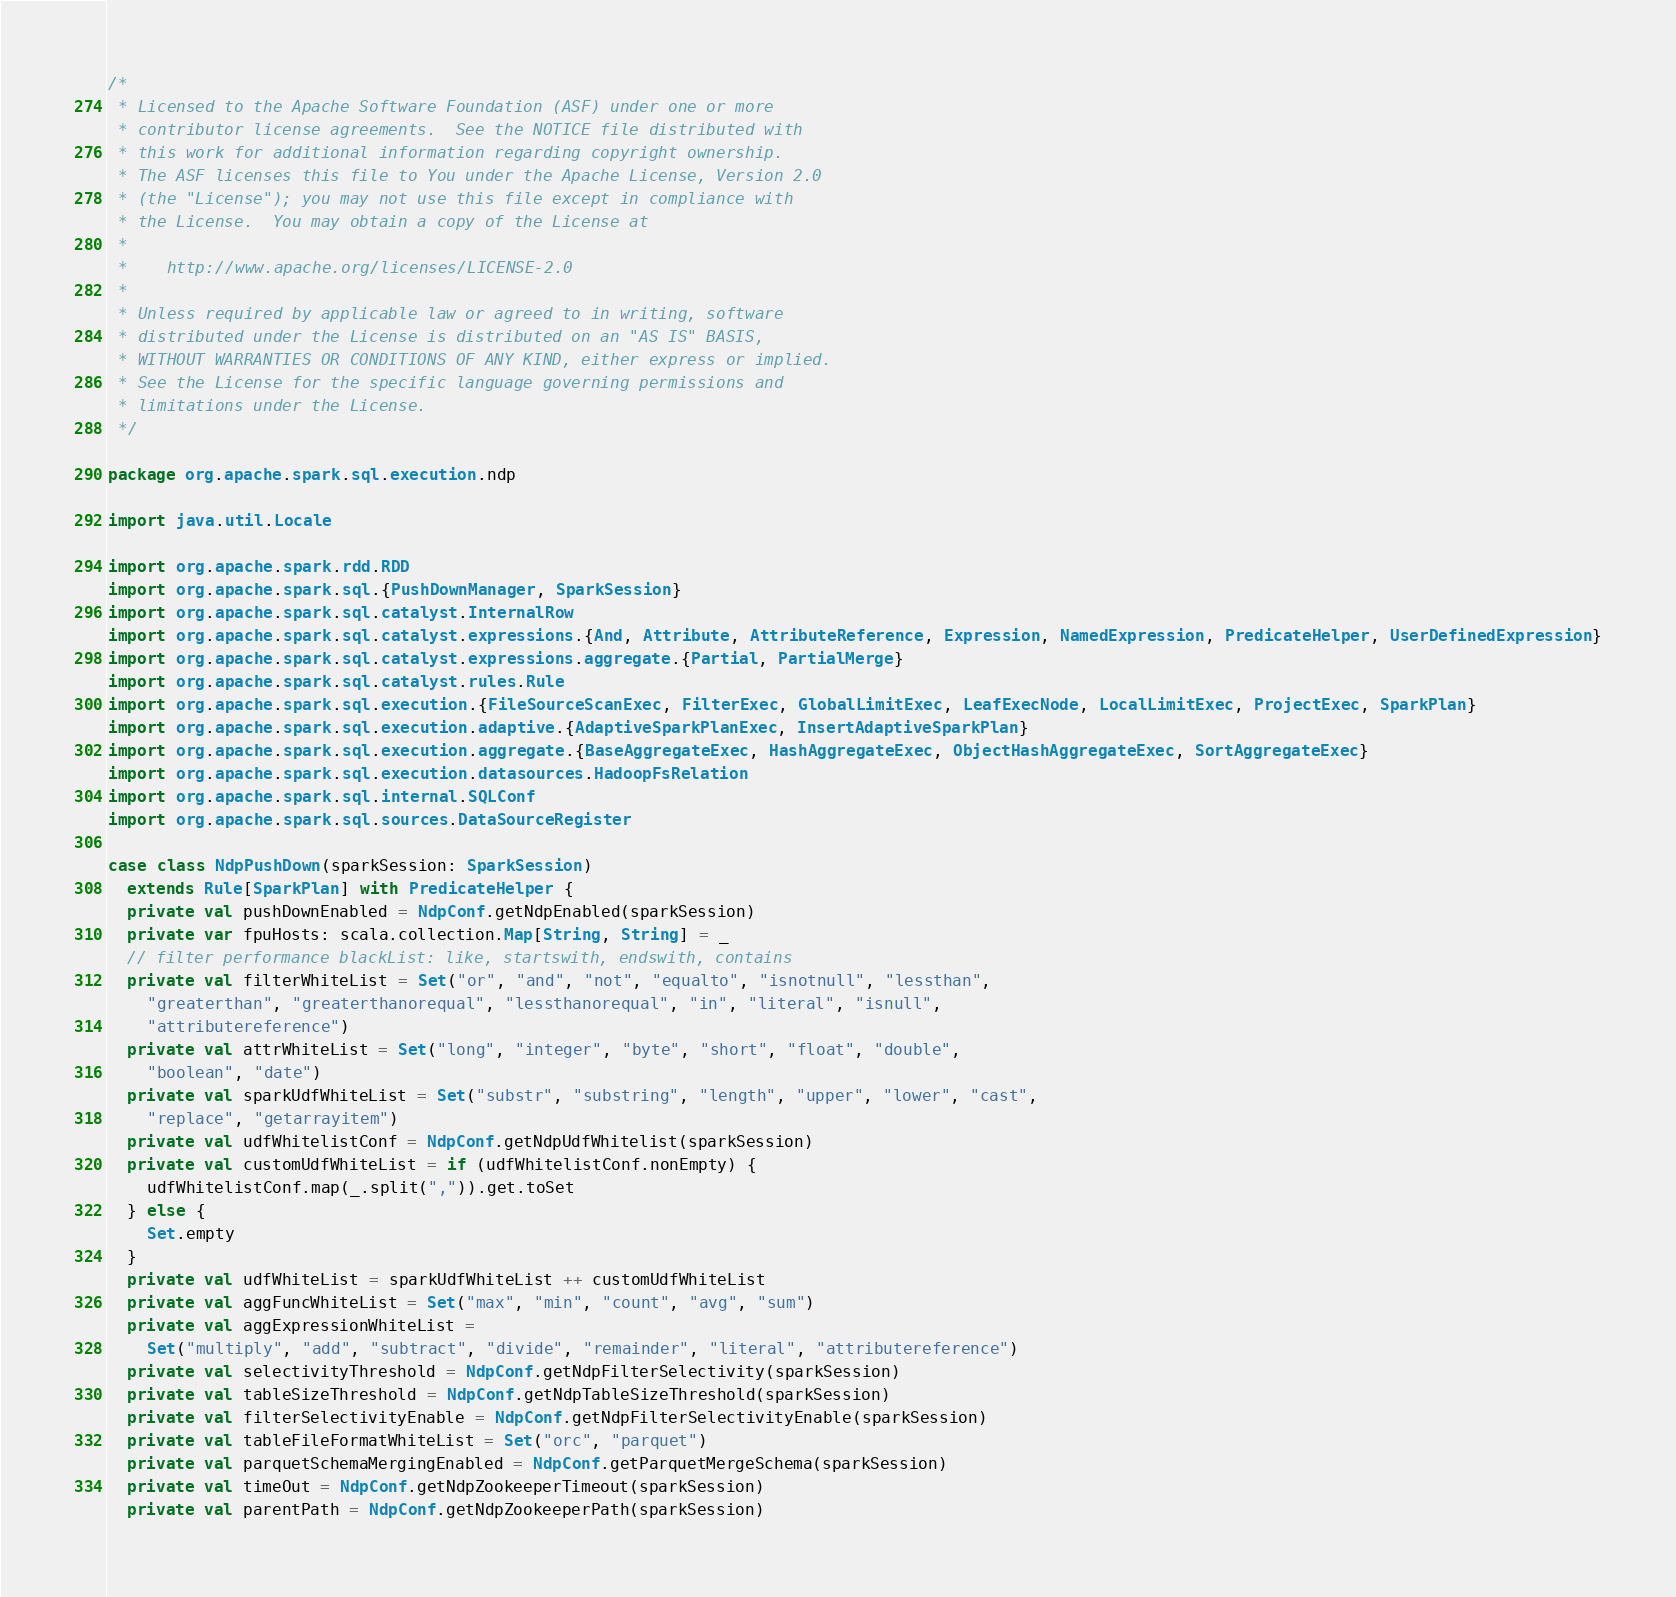Convert code to text. <code><loc_0><loc_0><loc_500><loc_500><_Scala_>/*
 * Licensed to the Apache Software Foundation (ASF) under one or more
 * contributor license agreements.  See the NOTICE file distributed with
 * this work for additional information regarding copyright ownership.
 * The ASF licenses this file to You under the Apache License, Version 2.0
 * (the "License"); you may not use this file except in compliance with
 * the License.  You may obtain a copy of the License at
 *
 *    http://www.apache.org/licenses/LICENSE-2.0
 *
 * Unless required by applicable law or agreed to in writing, software
 * distributed under the License is distributed on an "AS IS" BASIS,
 * WITHOUT WARRANTIES OR CONDITIONS OF ANY KIND, either express or implied.
 * See the License for the specific language governing permissions and
 * limitations under the License.
 */

package org.apache.spark.sql.execution.ndp

import java.util.Locale

import org.apache.spark.rdd.RDD
import org.apache.spark.sql.{PushDownManager, SparkSession}
import org.apache.spark.sql.catalyst.InternalRow
import org.apache.spark.sql.catalyst.expressions.{And, Attribute, AttributeReference, Expression, NamedExpression, PredicateHelper, UserDefinedExpression}
import org.apache.spark.sql.catalyst.expressions.aggregate.{Partial, PartialMerge}
import org.apache.spark.sql.catalyst.rules.Rule
import org.apache.spark.sql.execution.{FileSourceScanExec, FilterExec, GlobalLimitExec, LeafExecNode, LocalLimitExec, ProjectExec, SparkPlan}
import org.apache.spark.sql.execution.adaptive.{AdaptiveSparkPlanExec, InsertAdaptiveSparkPlan}
import org.apache.spark.sql.execution.aggregate.{BaseAggregateExec, HashAggregateExec, ObjectHashAggregateExec, SortAggregateExec}
import org.apache.spark.sql.execution.datasources.HadoopFsRelation
import org.apache.spark.sql.internal.SQLConf
import org.apache.spark.sql.sources.DataSourceRegister

case class NdpPushDown(sparkSession: SparkSession)
  extends Rule[SparkPlan] with PredicateHelper {
  private val pushDownEnabled = NdpConf.getNdpEnabled(sparkSession)
  private var fpuHosts: scala.collection.Map[String, String] = _
  // filter performance blackList: like, startswith, endswith, contains
  private val filterWhiteList = Set("or", "and", "not", "equalto", "isnotnull", "lessthan",
    "greaterthan", "greaterthanorequal", "lessthanorequal", "in", "literal", "isnull",
    "attributereference")
  private val attrWhiteList = Set("long", "integer", "byte", "short", "float", "double",
    "boolean", "date")
  private val sparkUdfWhiteList = Set("substr", "substring", "length", "upper", "lower", "cast",
    "replace", "getarrayitem")
  private val udfWhitelistConf = NdpConf.getNdpUdfWhitelist(sparkSession)
  private val customUdfWhiteList = if (udfWhitelistConf.nonEmpty) {
    udfWhitelistConf.map(_.split(",")).get.toSet
  } else {
    Set.empty
  }
  private val udfWhiteList = sparkUdfWhiteList ++ customUdfWhiteList
  private val aggFuncWhiteList = Set("max", "min", "count", "avg", "sum")
  private val aggExpressionWhiteList =
    Set("multiply", "add", "subtract", "divide", "remainder", "literal", "attributereference")
  private val selectivityThreshold = NdpConf.getNdpFilterSelectivity(sparkSession)
  private val tableSizeThreshold = NdpConf.getNdpTableSizeThreshold(sparkSession)
  private val filterSelectivityEnable = NdpConf.getNdpFilterSelectivityEnable(sparkSession)
  private val tableFileFormatWhiteList = Set("orc", "parquet")
  private val parquetSchemaMergingEnabled = NdpConf.getParquetMergeSchema(sparkSession)
  private val timeOut = NdpConf.getNdpZookeeperTimeout(sparkSession)
  private val parentPath = NdpConf.getNdpZookeeperPath(sparkSession)</code> 